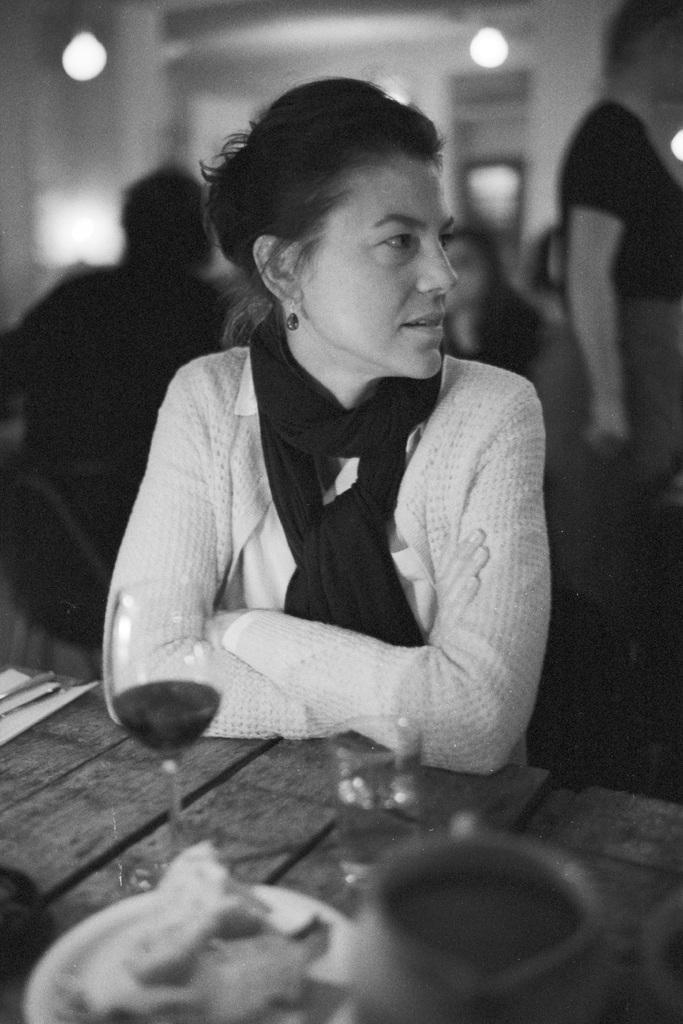In one or two sentences, can you explain what this image depicts? In this image i can see a woman and a table on which there is a glass and a cup. In the background i can see few other people and few lights. 